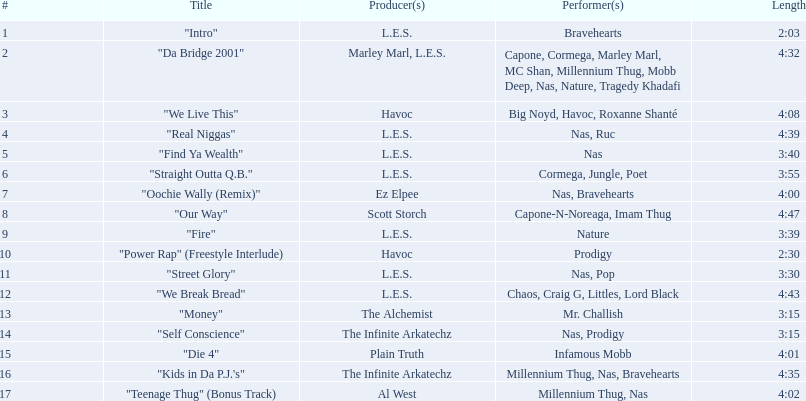Which is longer, fire or die 4? "Die 4". 